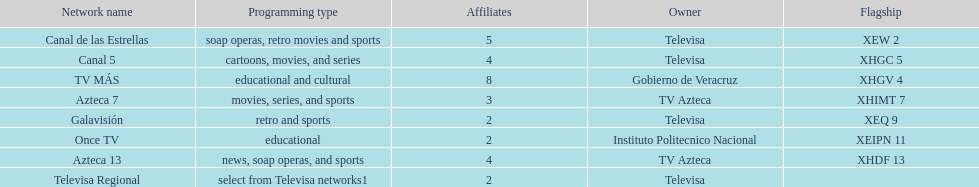How many networks have more affiliates than canal de las estrellas? 1. 